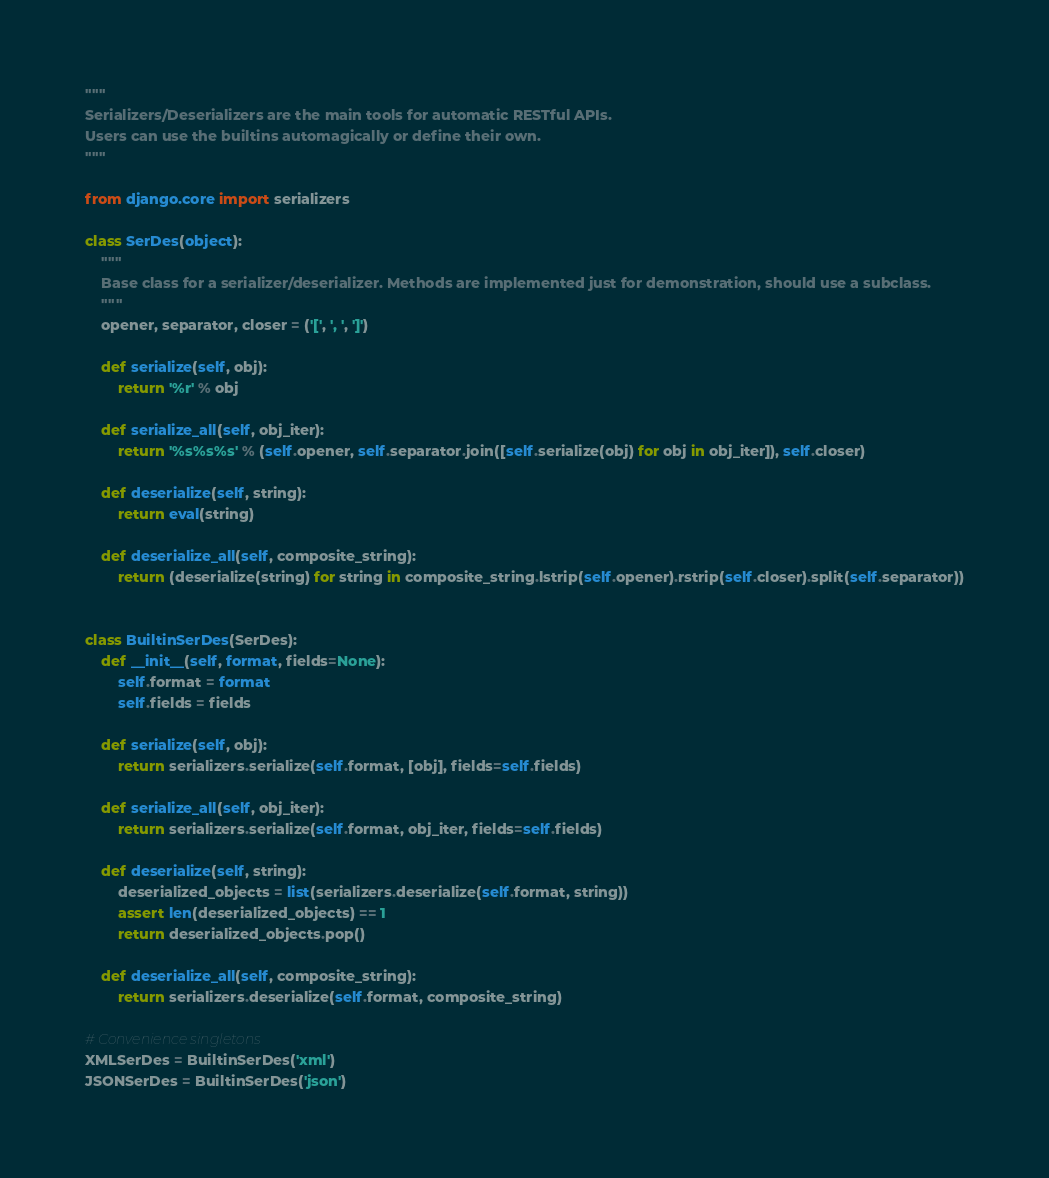<code> <loc_0><loc_0><loc_500><loc_500><_Python_>"""
Serializers/Deserializers are the main tools for automatic RESTful APIs.
Users can use the builtins automagically or define their own.
"""

from django.core import serializers

class SerDes(object):
    """
    Base class for a serializer/deserializer. Methods are implemented just for demonstration, should use a subclass.
    """
    opener, separator, closer = ('[', ', ', ']')

    def serialize(self, obj):
        return '%r' % obj

    def serialize_all(self, obj_iter):
        return '%s%s%s' % (self.opener, self.separator.join([self.serialize(obj) for obj in obj_iter]), self.closer)

    def deserialize(self, string):
        return eval(string)

    def deserialize_all(self, composite_string):
        return (deserialize(string) for string in composite_string.lstrip(self.opener).rstrip(self.closer).split(self.separator))


class BuiltinSerDes(SerDes):
    def __init__(self, format, fields=None):
        self.format = format
        self.fields = fields

    def serialize(self, obj):
        return serializers.serialize(self.format, [obj], fields=self.fields)

    def serialize_all(self, obj_iter):
        return serializers.serialize(self.format, obj_iter, fields=self.fields)

    def deserialize(self, string):
        deserialized_objects = list(serializers.deserialize(self.format, string))
        assert len(deserialized_objects) == 1
        return deserialized_objects.pop()

    def deserialize_all(self, composite_string):
        return serializers.deserialize(self.format, composite_string)

# Convenience singletons
XMLSerDes = BuiltinSerDes('xml')
JSONSerDes = BuiltinSerDes('json')
</code> 